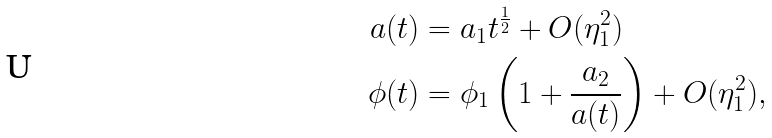<formula> <loc_0><loc_0><loc_500><loc_500>a ( t ) & = a _ { 1 } t ^ { \frac { 1 } { 2 } } + O ( \eta _ { 1 } ^ { 2 } ) \\ \phi ( t ) & = \phi _ { 1 } \left ( 1 + \frac { a _ { 2 } } { a ( t ) } \right ) + O ( \eta _ { 1 } ^ { 2 } ) ,</formula> 